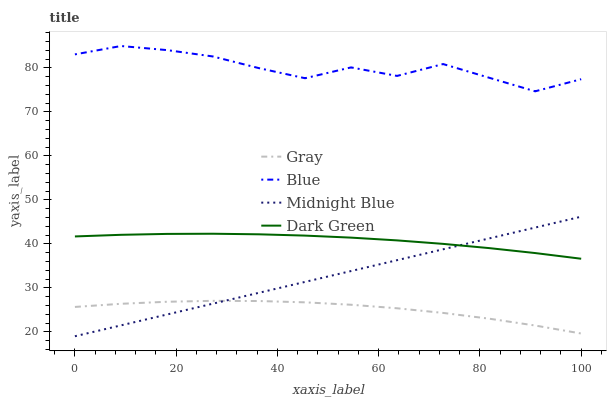Does Gray have the minimum area under the curve?
Answer yes or no. Yes. Does Blue have the maximum area under the curve?
Answer yes or no. Yes. Does Midnight Blue have the minimum area under the curve?
Answer yes or no. No. Does Midnight Blue have the maximum area under the curve?
Answer yes or no. No. Is Midnight Blue the smoothest?
Answer yes or no. Yes. Is Blue the roughest?
Answer yes or no. Yes. Is Gray the smoothest?
Answer yes or no. No. Is Gray the roughest?
Answer yes or no. No. Does Midnight Blue have the lowest value?
Answer yes or no. Yes. Does Gray have the lowest value?
Answer yes or no. No. Does Blue have the highest value?
Answer yes or no. Yes. Does Midnight Blue have the highest value?
Answer yes or no. No. Is Midnight Blue less than Blue?
Answer yes or no. Yes. Is Dark Green greater than Gray?
Answer yes or no. Yes. Does Dark Green intersect Midnight Blue?
Answer yes or no. Yes. Is Dark Green less than Midnight Blue?
Answer yes or no. No. Is Dark Green greater than Midnight Blue?
Answer yes or no. No. Does Midnight Blue intersect Blue?
Answer yes or no. No. 